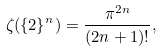Convert formula to latex. <formula><loc_0><loc_0><loc_500><loc_500>\zeta ( \{ 2 \} ^ { n } ) = \frac { \pi ^ { 2 n } } { ( 2 n + 1 ) ! } ,</formula> 